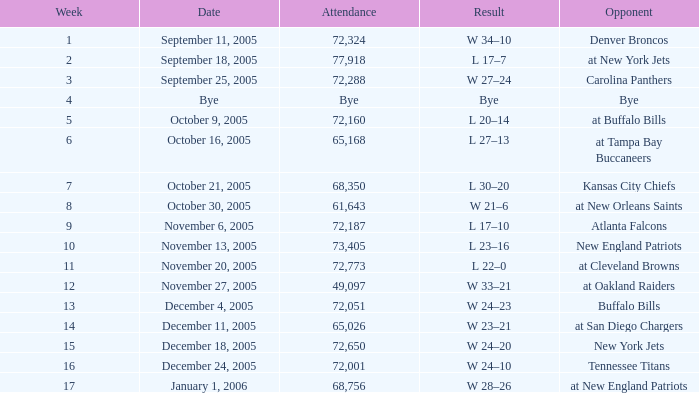Who was the Opponent on November 27, 2005? At oakland raiders. 